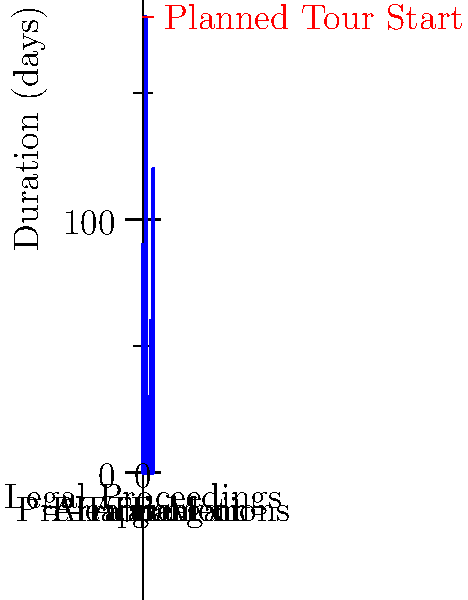Based on the timeline graph, which legal proceeding would have the most significant impact on the musician's touring schedule, assuming the tour was planned to start 180 days from now? To determine which legal proceeding would have the most significant impact on the musician's touring schedule, we need to follow these steps:

1. Identify the planned tour start date: The red dashed line indicates that the tour is planned to start 180 days from now.

2. Examine the duration of each legal proceeding:
   - Trial: 90 days
   - Appeal: 180 days
   - Arraignment: 30 days
   - Plea Bargain: 60 days
   - Pre-Trial Motions: 120 days

3. Compare each proceeding's duration to the tour start date:
   - Trial (90 days) would end before the tour starts
   - Appeal (180 days) would end exactly when the tour is supposed to start
   - Arraignment (30 days) would end well before the tour starts
   - Plea Bargain (60 days) would end before the tour starts
   - Pre-Trial Motions (120 days) would end before the tour starts

4. Identify the proceeding that extends to or beyond the tour start date:
   The Appeal process is the only proceeding that reaches the 180-day mark when the tour is planned to start.

Therefore, the Appeal would have the most significant impact on the musician's touring schedule, as it would potentially prevent the tour from starting on time or require rescheduling.
Answer: Appeal 